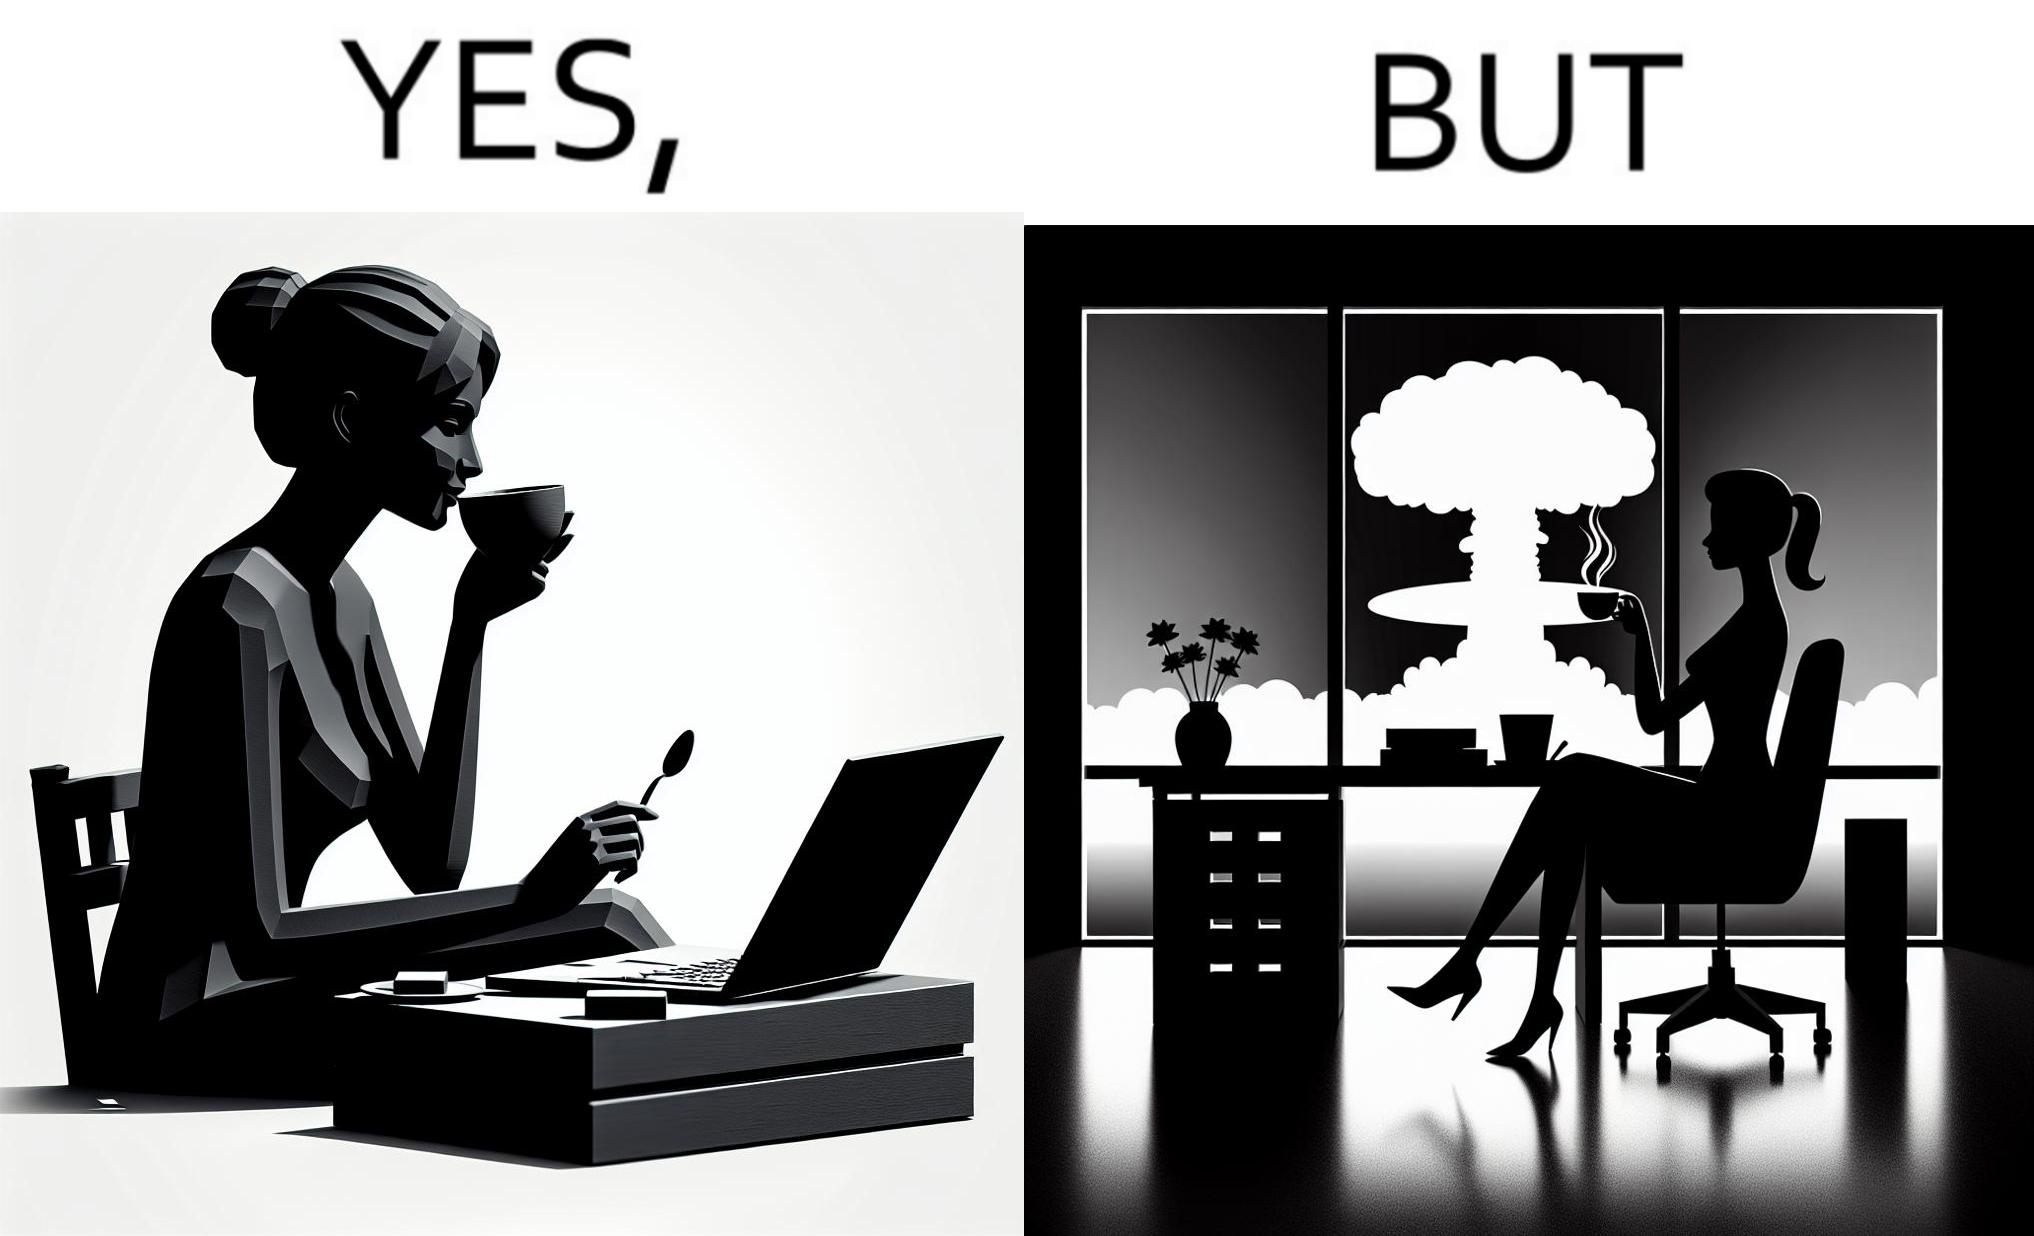What is the satirical meaning behind this image? The images are funny since it shows a woman simply sipping from a cup at ease in a cafe with her laptop not caring about anything going on outside the cafe even though the situation is very grave,that is, a nuclear blast 